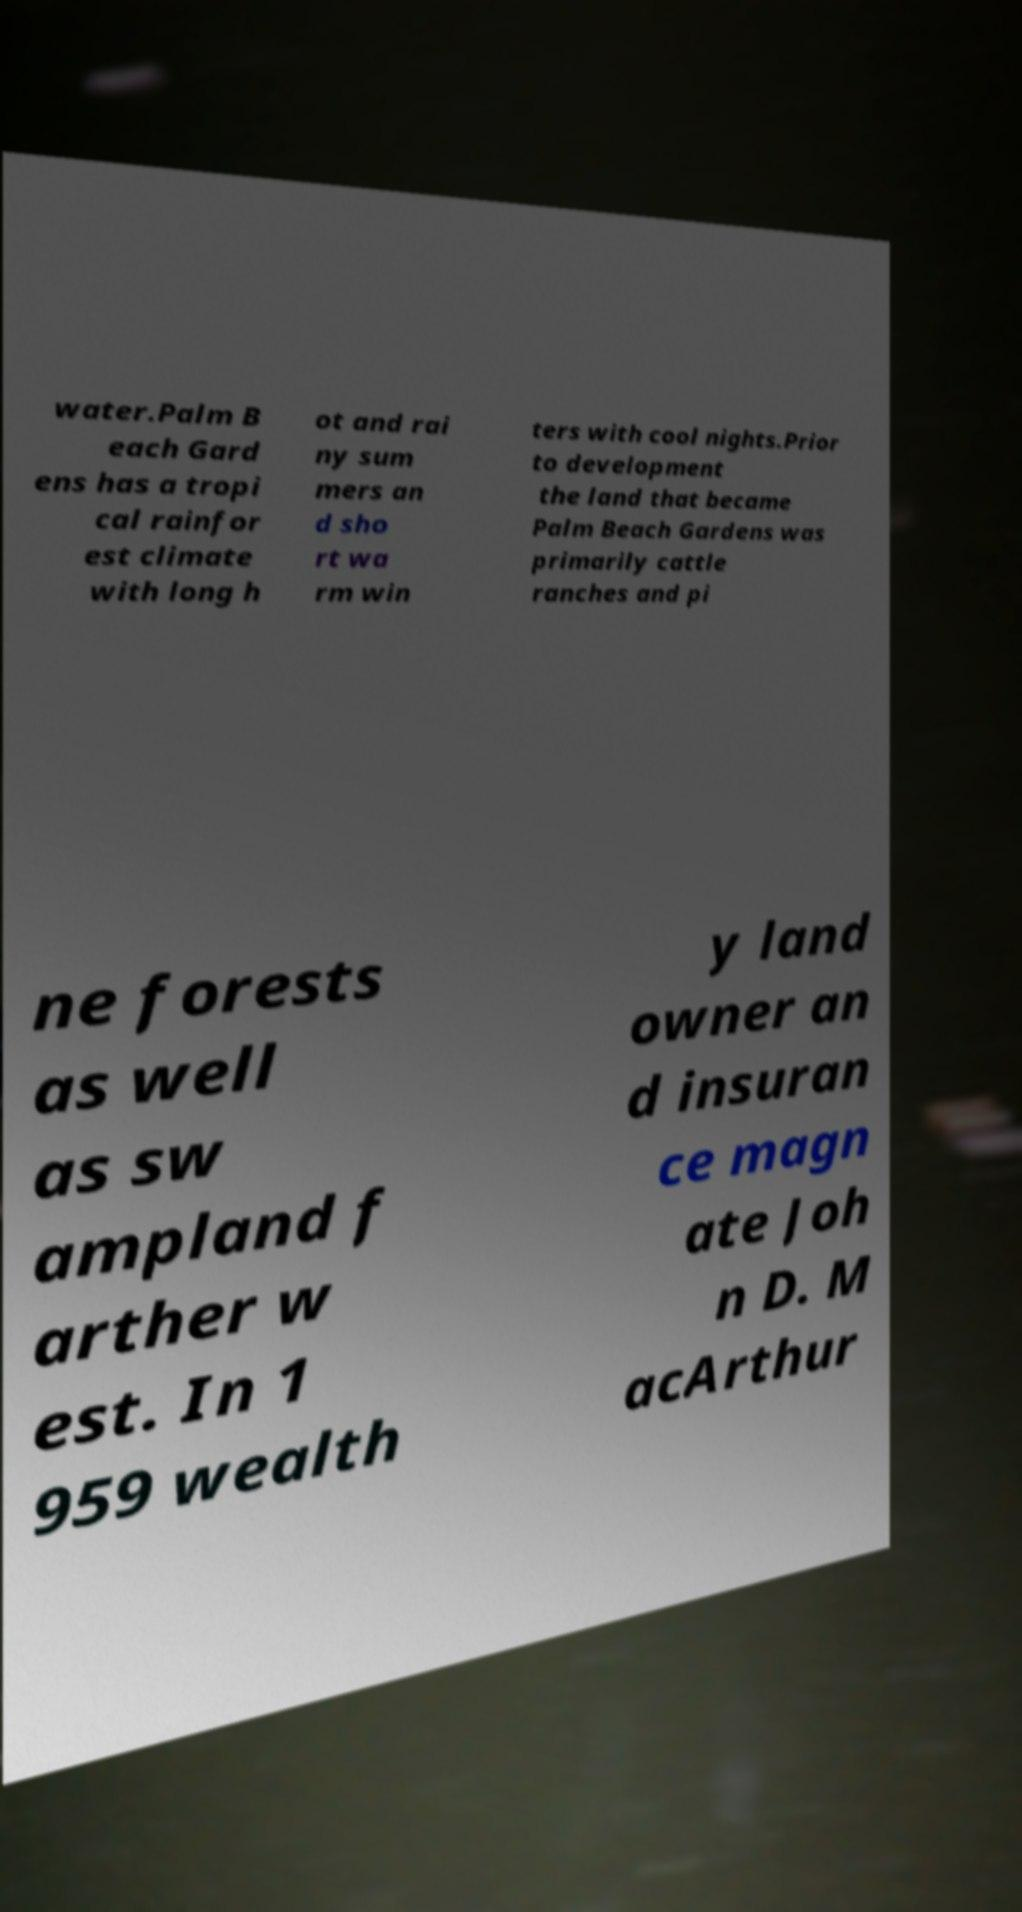Could you assist in decoding the text presented in this image and type it out clearly? water.Palm B each Gard ens has a tropi cal rainfor est climate with long h ot and rai ny sum mers an d sho rt wa rm win ters with cool nights.Prior to development the land that became Palm Beach Gardens was primarily cattle ranches and pi ne forests as well as sw ampland f arther w est. In 1 959 wealth y land owner an d insuran ce magn ate Joh n D. M acArthur 